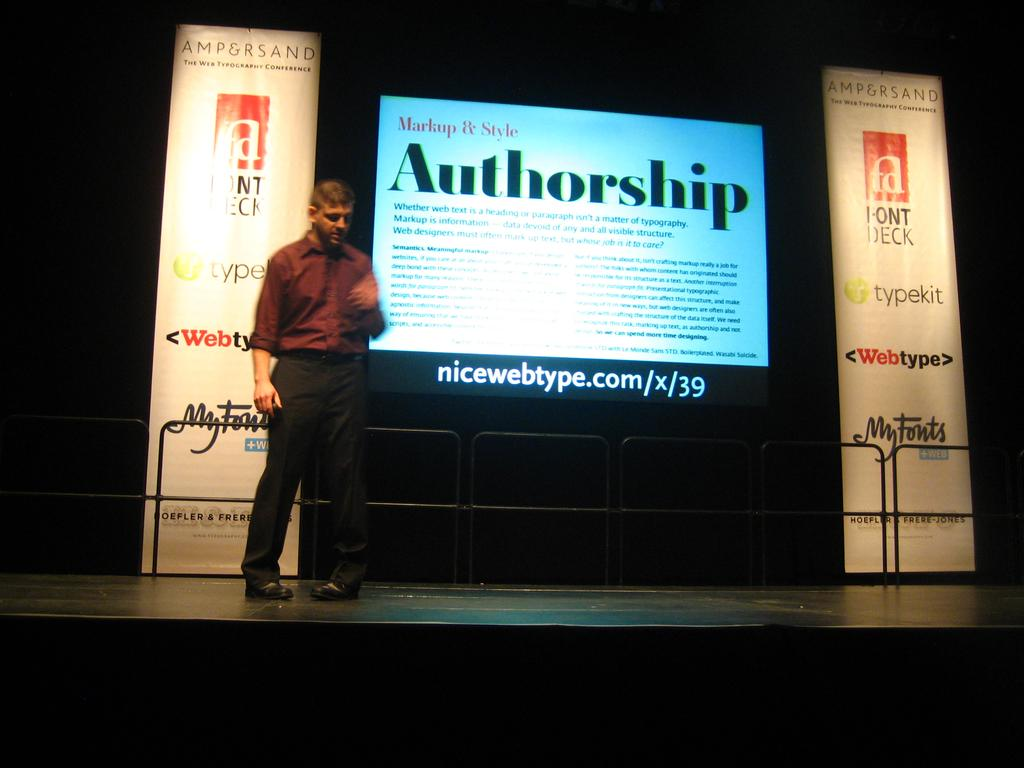What is the main object in the image? There is a screen in the image. What else can be seen in the image besides the screen? There is a banner in the image. Can you describe the person in the image? There is a person standing in the front of the image. What type of vegetable is being washed by the person in the image? There is no vegetable or washing activity present in the image. 